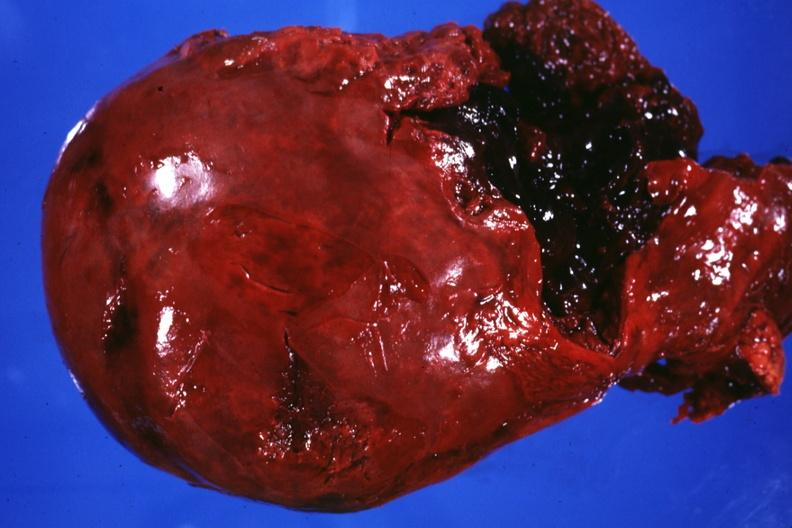s liver present?
Answer the question using a single word or phrase. Yes 